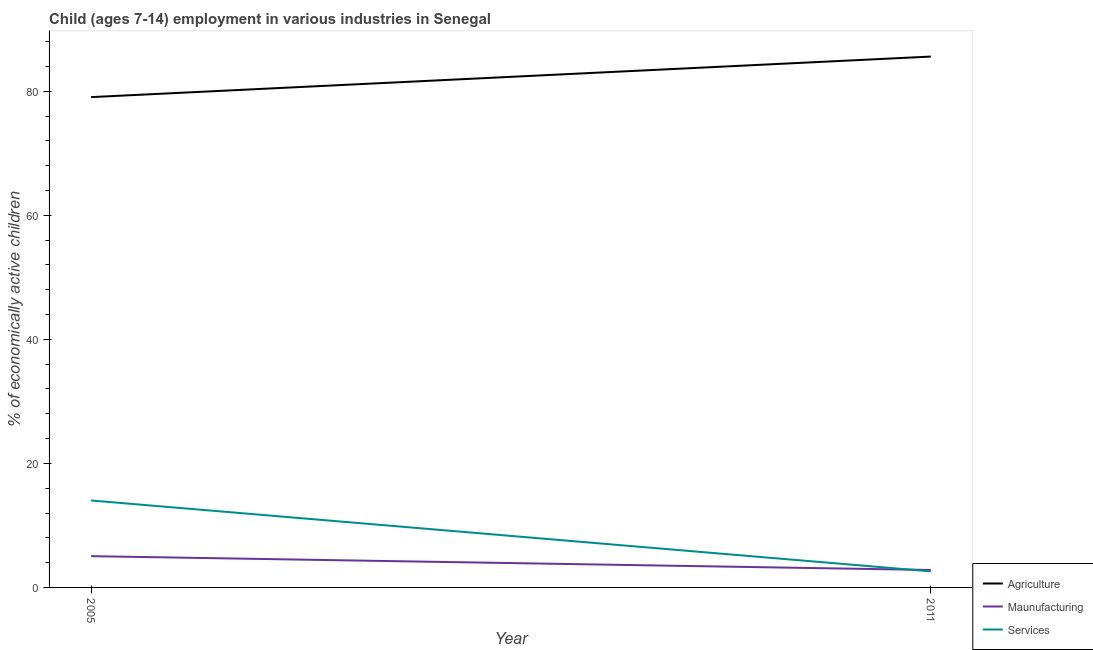How many different coloured lines are there?
Your answer should be compact. 3. Does the line corresponding to percentage of economically active children in services intersect with the line corresponding to percentage of economically active children in agriculture?
Ensure brevity in your answer.  No. What is the percentage of economically active children in agriculture in 2005?
Give a very brief answer. 79.06. Across all years, what is the maximum percentage of economically active children in agriculture?
Keep it short and to the point. 85.6. Across all years, what is the minimum percentage of economically active children in agriculture?
Your answer should be very brief. 79.06. In which year was the percentage of economically active children in manufacturing minimum?
Ensure brevity in your answer.  2011. What is the total percentage of economically active children in manufacturing in the graph?
Ensure brevity in your answer.  7.85. What is the difference between the percentage of economically active children in manufacturing in 2005 and that in 2011?
Give a very brief answer. 2.23. What is the difference between the percentage of economically active children in services in 2011 and the percentage of economically active children in agriculture in 2005?
Ensure brevity in your answer.  -76.47. What is the average percentage of economically active children in agriculture per year?
Make the answer very short. 82.33. In the year 2011, what is the difference between the percentage of economically active children in services and percentage of economically active children in manufacturing?
Offer a terse response. -0.22. In how many years, is the percentage of economically active children in manufacturing greater than 40 %?
Keep it short and to the point. 0. What is the ratio of the percentage of economically active children in services in 2005 to that in 2011?
Make the answer very short. 5.41. Is the percentage of economically active children in services in 2005 less than that in 2011?
Your answer should be very brief. No. In how many years, is the percentage of economically active children in manufacturing greater than the average percentage of economically active children in manufacturing taken over all years?
Give a very brief answer. 1. Is the percentage of economically active children in agriculture strictly less than the percentage of economically active children in services over the years?
Keep it short and to the point. No. How many lines are there?
Offer a very short reply. 3. Are the values on the major ticks of Y-axis written in scientific E-notation?
Keep it short and to the point. No. Does the graph contain any zero values?
Your answer should be very brief. No. Where does the legend appear in the graph?
Your answer should be compact. Bottom right. How many legend labels are there?
Your answer should be very brief. 3. How are the legend labels stacked?
Give a very brief answer. Vertical. What is the title of the graph?
Provide a short and direct response. Child (ages 7-14) employment in various industries in Senegal. Does "Manufactures" appear as one of the legend labels in the graph?
Ensure brevity in your answer.  No. What is the label or title of the X-axis?
Keep it short and to the point. Year. What is the label or title of the Y-axis?
Your response must be concise. % of economically active children. What is the % of economically active children of Agriculture in 2005?
Offer a very short reply. 79.06. What is the % of economically active children in Maunufacturing in 2005?
Give a very brief answer. 5.04. What is the % of economically active children of Services in 2005?
Make the answer very short. 14.02. What is the % of economically active children in Agriculture in 2011?
Your answer should be compact. 85.6. What is the % of economically active children in Maunufacturing in 2011?
Provide a short and direct response. 2.81. What is the % of economically active children in Services in 2011?
Keep it short and to the point. 2.59. Across all years, what is the maximum % of economically active children of Agriculture?
Your response must be concise. 85.6. Across all years, what is the maximum % of economically active children in Maunufacturing?
Ensure brevity in your answer.  5.04. Across all years, what is the maximum % of economically active children of Services?
Provide a short and direct response. 14.02. Across all years, what is the minimum % of economically active children of Agriculture?
Keep it short and to the point. 79.06. Across all years, what is the minimum % of economically active children of Maunufacturing?
Give a very brief answer. 2.81. Across all years, what is the minimum % of economically active children in Services?
Ensure brevity in your answer.  2.59. What is the total % of economically active children of Agriculture in the graph?
Provide a succinct answer. 164.66. What is the total % of economically active children in Maunufacturing in the graph?
Ensure brevity in your answer.  7.85. What is the total % of economically active children in Services in the graph?
Provide a short and direct response. 16.61. What is the difference between the % of economically active children of Agriculture in 2005 and that in 2011?
Offer a terse response. -6.54. What is the difference between the % of economically active children in Maunufacturing in 2005 and that in 2011?
Your answer should be compact. 2.23. What is the difference between the % of economically active children of Services in 2005 and that in 2011?
Your answer should be very brief. 11.43. What is the difference between the % of economically active children of Agriculture in 2005 and the % of economically active children of Maunufacturing in 2011?
Keep it short and to the point. 76.25. What is the difference between the % of economically active children of Agriculture in 2005 and the % of economically active children of Services in 2011?
Offer a terse response. 76.47. What is the difference between the % of economically active children of Maunufacturing in 2005 and the % of economically active children of Services in 2011?
Provide a short and direct response. 2.45. What is the average % of economically active children of Agriculture per year?
Offer a terse response. 82.33. What is the average % of economically active children in Maunufacturing per year?
Keep it short and to the point. 3.92. What is the average % of economically active children in Services per year?
Provide a succinct answer. 8.3. In the year 2005, what is the difference between the % of economically active children of Agriculture and % of economically active children of Maunufacturing?
Your answer should be very brief. 74.02. In the year 2005, what is the difference between the % of economically active children of Agriculture and % of economically active children of Services?
Provide a short and direct response. 65.04. In the year 2005, what is the difference between the % of economically active children of Maunufacturing and % of economically active children of Services?
Offer a very short reply. -8.98. In the year 2011, what is the difference between the % of economically active children of Agriculture and % of economically active children of Maunufacturing?
Provide a succinct answer. 82.79. In the year 2011, what is the difference between the % of economically active children in Agriculture and % of economically active children in Services?
Your answer should be compact. 83.01. In the year 2011, what is the difference between the % of economically active children of Maunufacturing and % of economically active children of Services?
Provide a succinct answer. 0.22. What is the ratio of the % of economically active children of Agriculture in 2005 to that in 2011?
Provide a short and direct response. 0.92. What is the ratio of the % of economically active children of Maunufacturing in 2005 to that in 2011?
Offer a very short reply. 1.79. What is the ratio of the % of economically active children in Services in 2005 to that in 2011?
Provide a succinct answer. 5.41. What is the difference between the highest and the second highest % of economically active children in Agriculture?
Your response must be concise. 6.54. What is the difference between the highest and the second highest % of economically active children in Maunufacturing?
Your answer should be very brief. 2.23. What is the difference between the highest and the second highest % of economically active children in Services?
Your answer should be very brief. 11.43. What is the difference between the highest and the lowest % of economically active children of Agriculture?
Give a very brief answer. 6.54. What is the difference between the highest and the lowest % of economically active children of Maunufacturing?
Offer a terse response. 2.23. What is the difference between the highest and the lowest % of economically active children of Services?
Offer a very short reply. 11.43. 